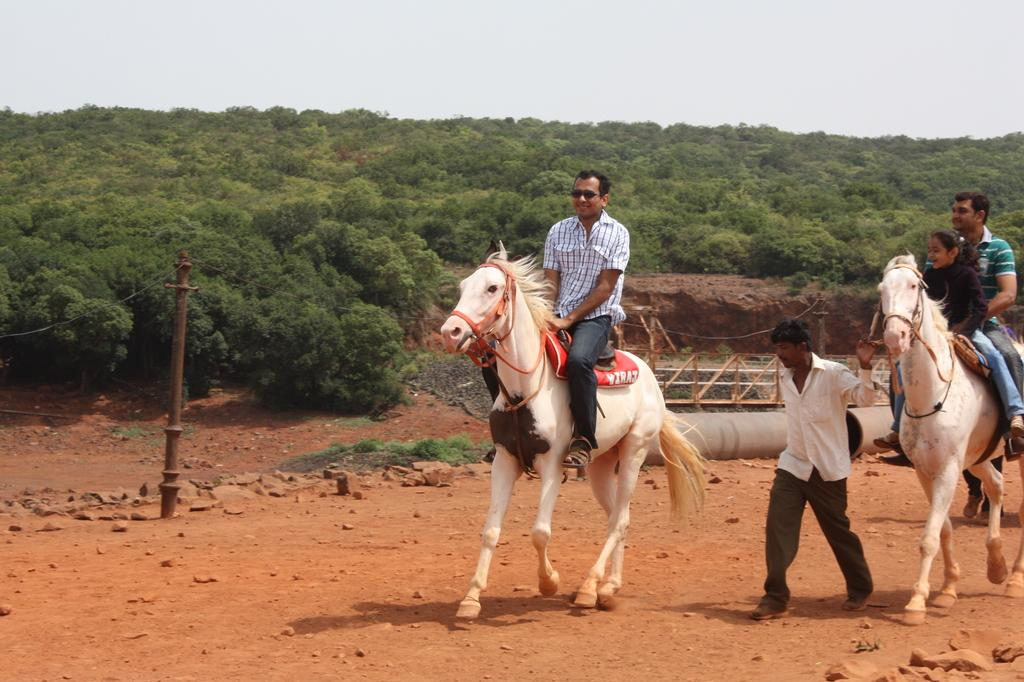What activity are the people engaged in within the image? The people are riding horses in the image. What is the guy doing in the image? The guy is catching a horse in the image. What color are the people and horses in the image? Both the people and the horses are in white color. What can be seen in the background of the image? There are many trees and small houses in the background of the image. How many cows are present in the image? There are no cows present in the image; it features people riding and catching horses. What shape is the shade in the image? There is no shade present in the image. 